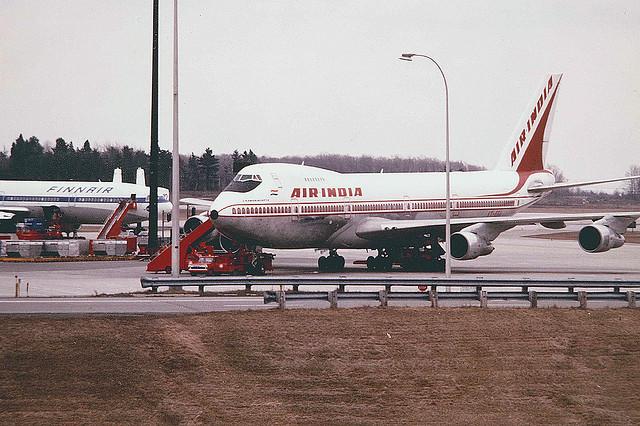What does the plane have written on it?
Give a very brief answer. Air india. What company owns the backplane?
Be succinct. Finnair. Are these planes flying?
Be succinct. No. 